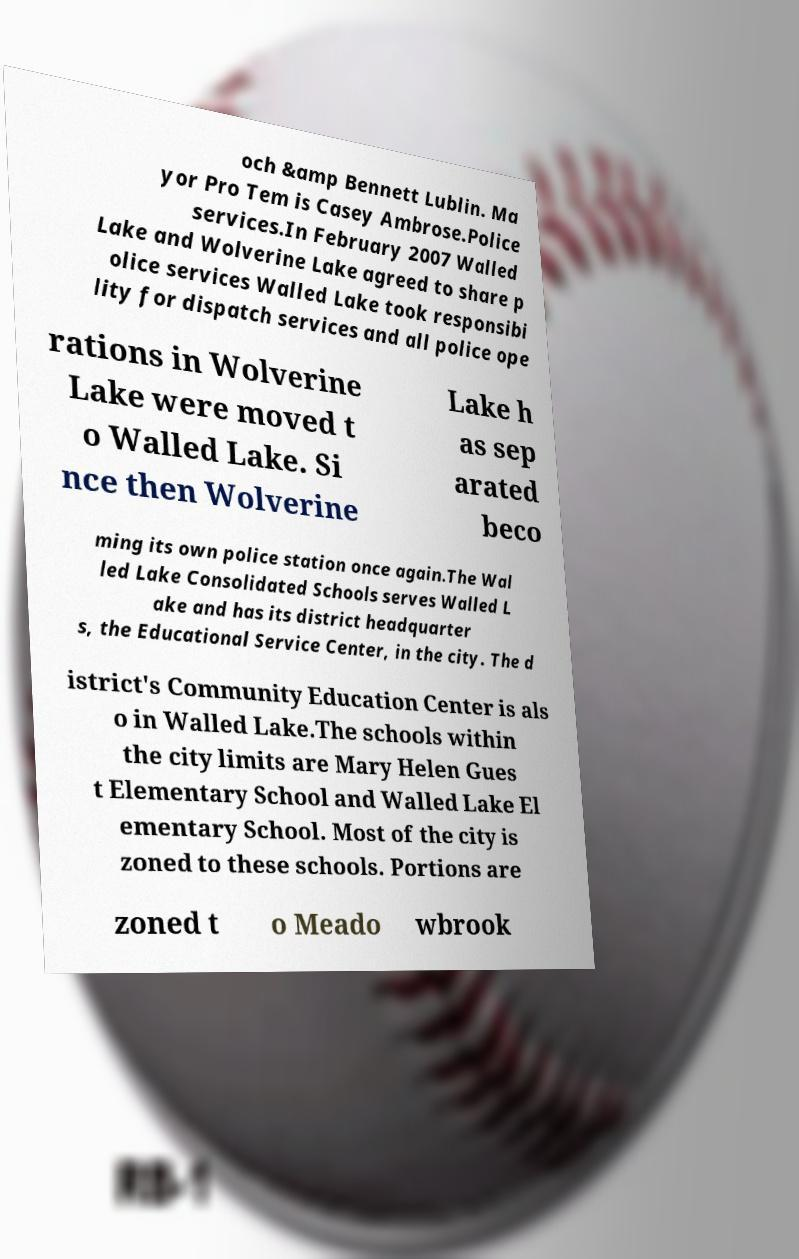Can you read and provide the text displayed in the image?This photo seems to have some interesting text. Can you extract and type it out for me? och &amp Bennett Lublin. Ma yor Pro Tem is Casey Ambrose.Police services.In February 2007 Walled Lake and Wolverine Lake agreed to share p olice services Walled Lake took responsibi lity for dispatch services and all police ope rations in Wolverine Lake were moved t o Walled Lake. Si nce then Wolverine Lake h as sep arated beco ming its own police station once again.The Wal led Lake Consolidated Schools serves Walled L ake and has its district headquarter s, the Educational Service Center, in the city. The d istrict's Community Education Center is als o in Walled Lake.The schools within the city limits are Mary Helen Gues t Elementary School and Walled Lake El ementary School. Most of the city is zoned to these schools. Portions are zoned t o Meado wbrook 